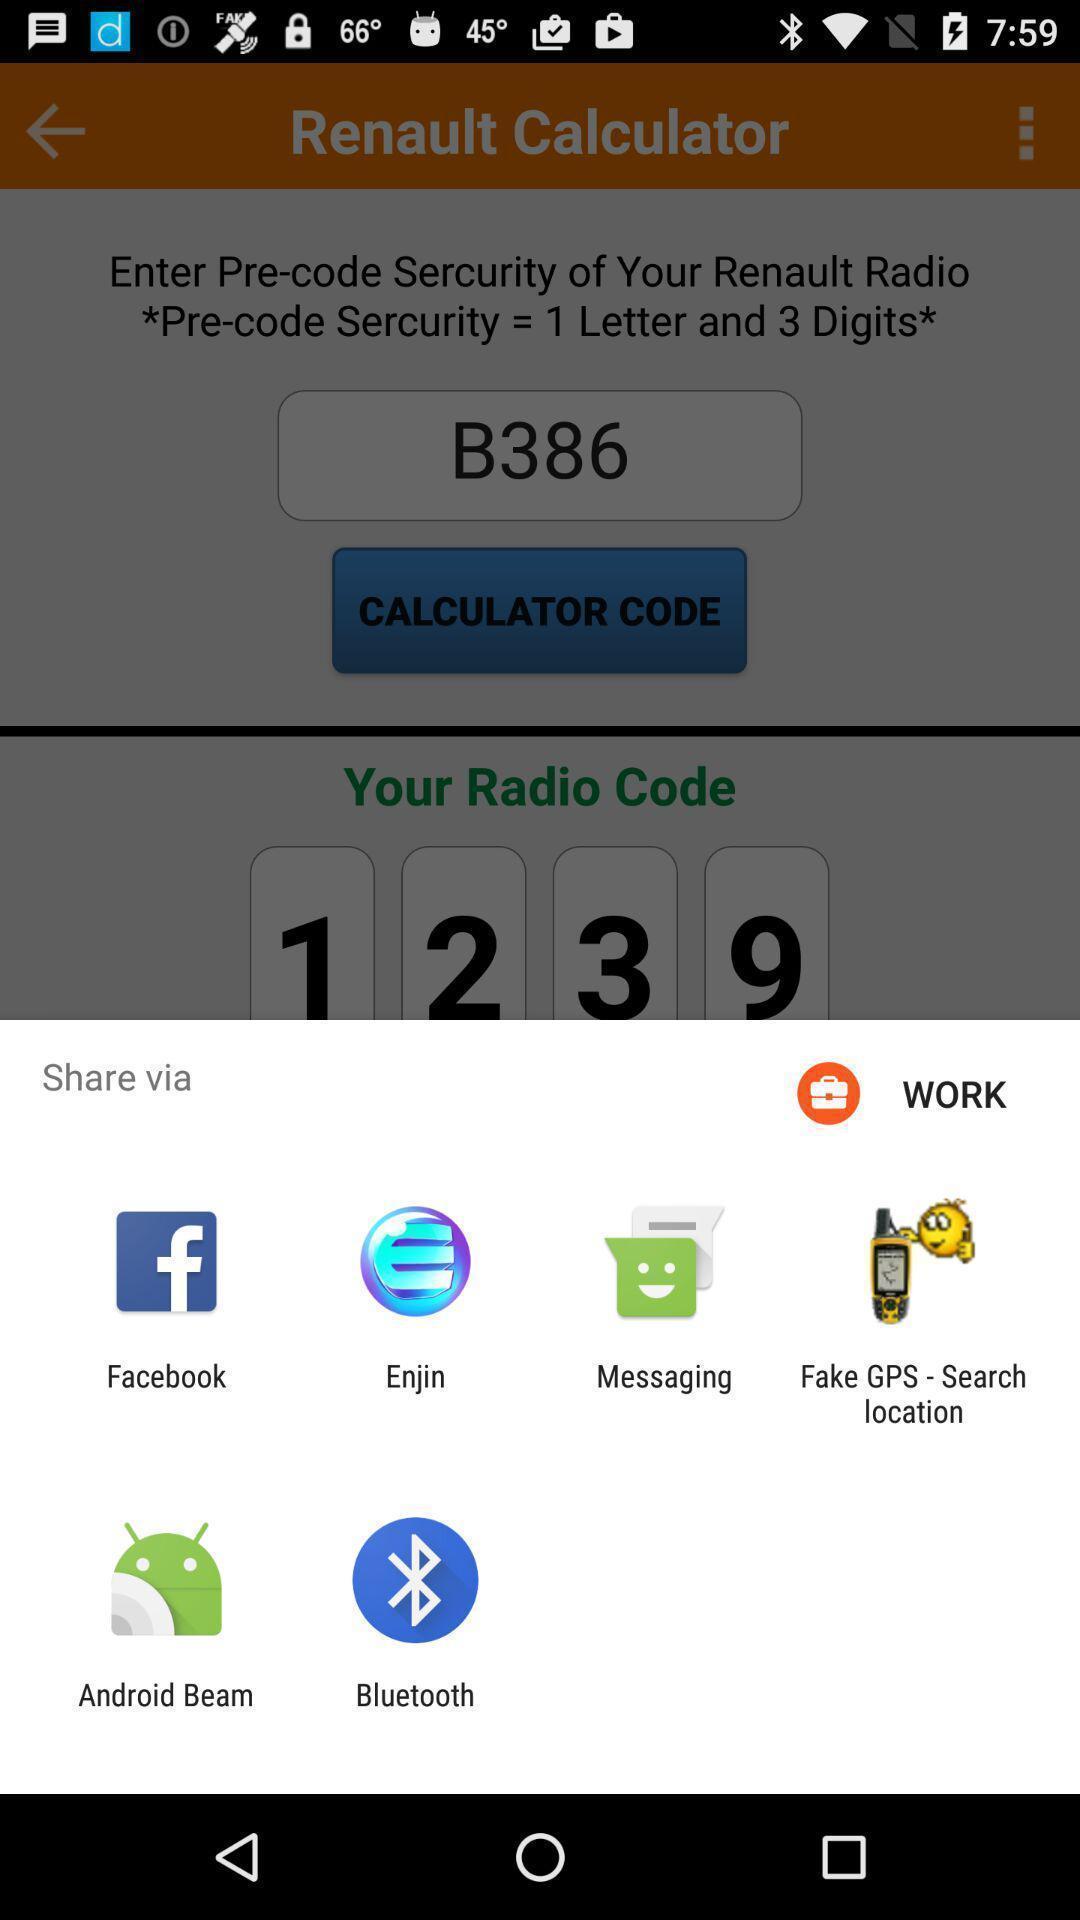Tell me about the visual elements in this screen capture. Share information with different apps. 